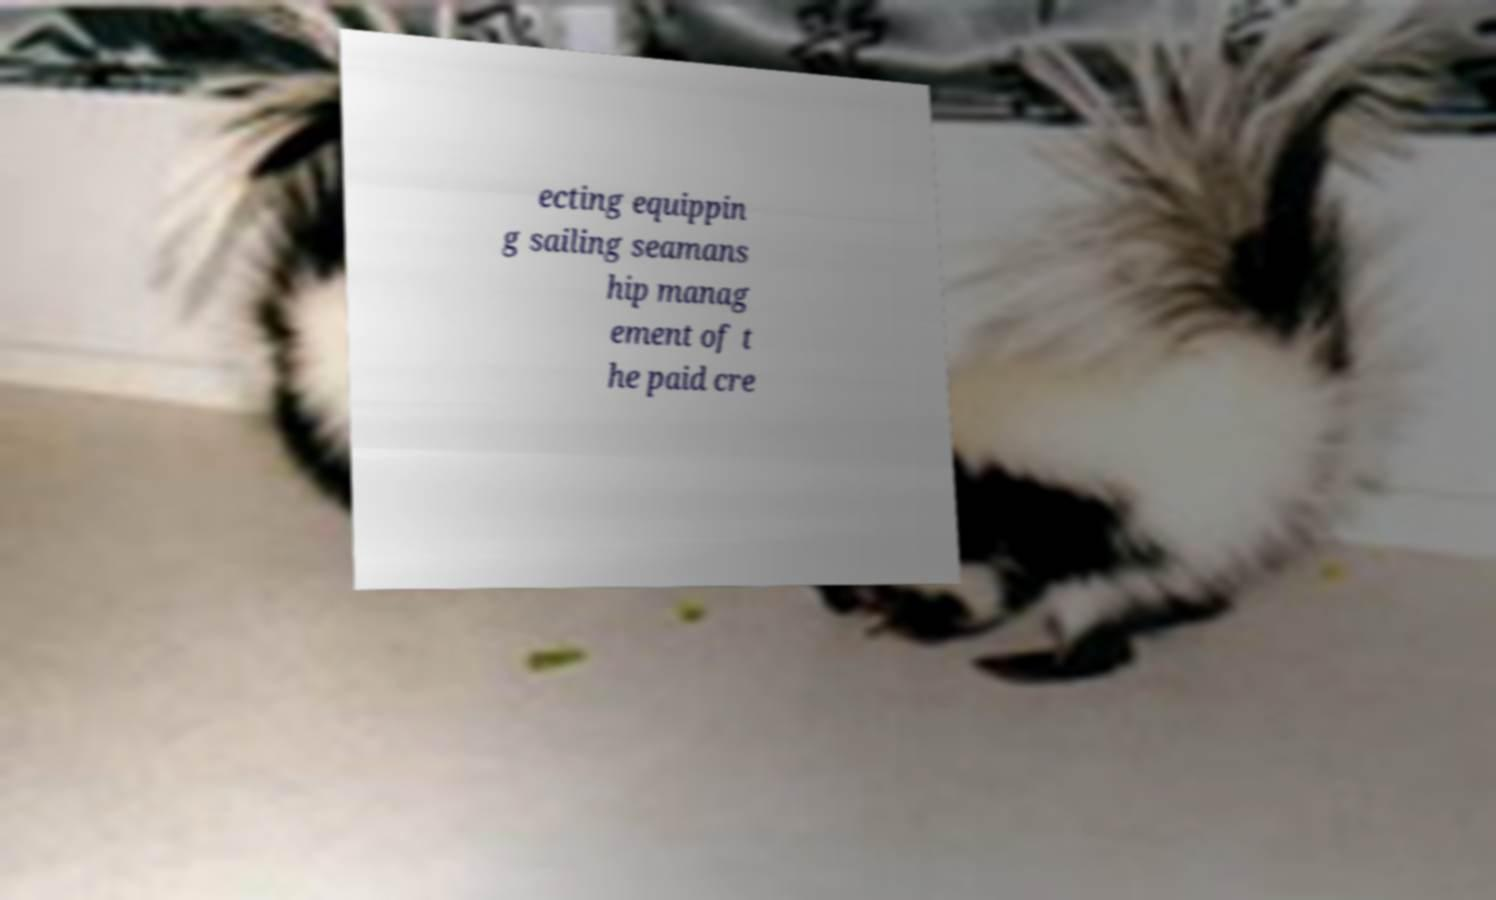Could you assist in decoding the text presented in this image and type it out clearly? ecting equippin g sailing seamans hip manag ement of t he paid cre 